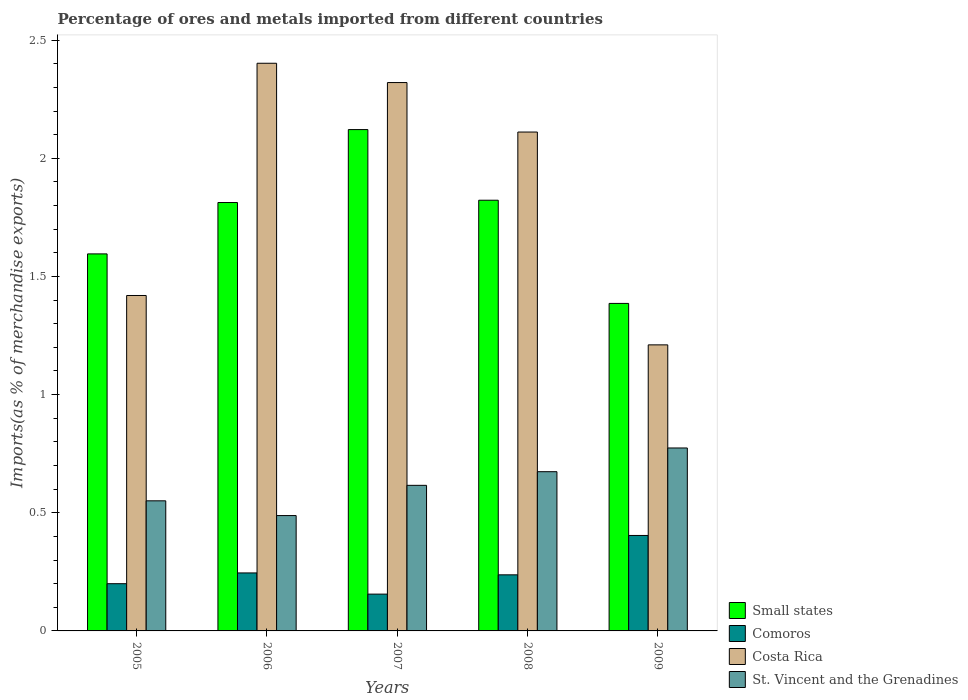How many different coloured bars are there?
Offer a very short reply. 4. How many groups of bars are there?
Ensure brevity in your answer.  5. How many bars are there on the 4th tick from the right?
Provide a short and direct response. 4. What is the label of the 2nd group of bars from the left?
Provide a succinct answer. 2006. In how many cases, is the number of bars for a given year not equal to the number of legend labels?
Your answer should be compact. 0. What is the percentage of imports to different countries in St. Vincent and the Grenadines in 2009?
Provide a succinct answer. 0.77. Across all years, what is the maximum percentage of imports to different countries in Small states?
Keep it short and to the point. 2.12. Across all years, what is the minimum percentage of imports to different countries in Costa Rica?
Your answer should be compact. 1.21. In which year was the percentage of imports to different countries in Small states maximum?
Provide a succinct answer. 2007. What is the total percentage of imports to different countries in Costa Rica in the graph?
Provide a succinct answer. 9.46. What is the difference between the percentage of imports to different countries in St. Vincent and the Grenadines in 2006 and that in 2007?
Your answer should be compact. -0.13. What is the difference between the percentage of imports to different countries in St. Vincent and the Grenadines in 2008 and the percentage of imports to different countries in Small states in 2006?
Make the answer very short. -1.14. What is the average percentage of imports to different countries in Comoros per year?
Provide a short and direct response. 0.25. In the year 2007, what is the difference between the percentage of imports to different countries in Comoros and percentage of imports to different countries in Small states?
Make the answer very short. -1.97. What is the ratio of the percentage of imports to different countries in Comoros in 2007 to that in 2009?
Your answer should be very brief. 0.39. What is the difference between the highest and the second highest percentage of imports to different countries in Comoros?
Your answer should be very brief. 0.16. What is the difference between the highest and the lowest percentage of imports to different countries in Comoros?
Your answer should be very brief. 0.25. Is the sum of the percentage of imports to different countries in St. Vincent and the Grenadines in 2006 and 2009 greater than the maximum percentage of imports to different countries in Comoros across all years?
Keep it short and to the point. Yes. What does the 4th bar from the left in 2005 represents?
Offer a very short reply. St. Vincent and the Grenadines. What does the 1st bar from the right in 2006 represents?
Keep it short and to the point. St. Vincent and the Grenadines. How many bars are there?
Offer a very short reply. 20. What is the difference between two consecutive major ticks on the Y-axis?
Ensure brevity in your answer.  0.5. Are the values on the major ticks of Y-axis written in scientific E-notation?
Provide a succinct answer. No. Does the graph contain any zero values?
Provide a succinct answer. No. Does the graph contain grids?
Provide a succinct answer. No. How are the legend labels stacked?
Ensure brevity in your answer.  Vertical. What is the title of the graph?
Provide a short and direct response. Percentage of ores and metals imported from different countries. Does "Kuwait" appear as one of the legend labels in the graph?
Your answer should be very brief. No. What is the label or title of the X-axis?
Ensure brevity in your answer.  Years. What is the label or title of the Y-axis?
Your answer should be compact. Imports(as % of merchandise exports). What is the Imports(as % of merchandise exports) in Small states in 2005?
Ensure brevity in your answer.  1.6. What is the Imports(as % of merchandise exports) of Comoros in 2005?
Keep it short and to the point. 0.2. What is the Imports(as % of merchandise exports) in Costa Rica in 2005?
Provide a short and direct response. 1.42. What is the Imports(as % of merchandise exports) in St. Vincent and the Grenadines in 2005?
Offer a terse response. 0.55. What is the Imports(as % of merchandise exports) of Small states in 2006?
Provide a short and direct response. 1.81. What is the Imports(as % of merchandise exports) in Comoros in 2006?
Your answer should be compact. 0.25. What is the Imports(as % of merchandise exports) in Costa Rica in 2006?
Provide a short and direct response. 2.4. What is the Imports(as % of merchandise exports) in St. Vincent and the Grenadines in 2006?
Make the answer very short. 0.49. What is the Imports(as % of merchandise exports) of Small states in 2007?
Make the answer very short. 2.12. What is the Imports(as % of merchandise exports) of Comoros in 2007?
Make the answer very short. 0.16. What is the Imports(as % of merchandise exports) in Costa Rica in 2007?
Your answer should be very brief. 2.32. What is the Imports(as % of merchandise exports) of St. Vincent and the Grenadines in 2007?
Give a very brief answer. 0.62. What is the Imports(as % of merchandise exports) of Small states in 2008?
Provide a succinct answer. 1.82. What is the Imports(as % of merchandise exports) of Comoros in 2008?
Keep it short and to the point. 0.24. What is the Imports(as % of merchandise exports) of Costa Rica in 2008?
Offer a terse response. 2.11. What is the Imports(as % of merchandise exports) in St. Vincent and the Grenadines in 2008?
Provide a succinct answer. 0.67. What is the Imports(as % of merchandise exports) in Small states in 2009?
Your answer should be very brief. 1.39. What is the Imports(as % of merchandise exports) of Comoros in 2009?
Keep it short and to the point. 0.4. What is the Imports(as % of merchandise exports) in Costa Rica in 2009?
Your response must be concise. 1.21. What is the Imports(as % of merchandise exports) of St. Vincent and the Grenadines in 2009?
Your answer should be very brief. 0.77. Across all years, what is the maximum Imports(as % of merchandise exports) in Small states?
Provide a short and direct response. 2.12. Across all years, what is the maximum Imports(as % of merchandise exports) in Comoros?
Provide a succinct answer. 0.4. Across all years, what is the maximum Imports(as % of merchandise exports) of Costa Rica?
Your answer should be very brief. 2.4. Across all years, what is the maximum Imports(as % of merchandise exports) of St. Vincent and the Grenadines?
Provide a short and direct response. 0.77. Across all years, what is the minimum Imports(as % of merchandise exports) of Small states?
Offer a terse response. 1.39. Across all years, what is the minimum Imports(as % of merchandise exports) of Comoros?
Keep it short and to the point. 0.16. Across all years, what is the minimum Imports(as % of merchandise exports) in Costa Rica?
Your answer should be compact. 1.21. Across all years, what is the minimum Imports(as % of merchandise exports) of St. Vincent and the Grenadines?
Your response must be concise. 0.49. What is the total Imports(as % of merchandise exports) in Small states in the graph?
Keep it short and to the point. 8.74. What is the total Imports(as % of merchandise exports) of Comoros in the graph?
Give a very brief answer. 1.24. What is the total Imports(as % of merchandise exports) in Costa Rica in the graph?
Make the answer very short. 9.46. What is the total Imports(as % of merchandise exports) of St. Vincent and the Grenadines in the graph?
Keep it short and to the point. 3.1. What is the difference between the Imports(as % of merchandise exports) in Small states in 2005 and that in 2006?
Offer a terse response. -0.22. What is the difference between the Imports(as % of merchandise exports) of Comoros in 2005 and that in 2006?
Provide a succinct answer. -0.05. What is the difference between the Imports(as % of merchandise exports) of Costa Rica in 2005 and that in 2006?
Offer a terse response. -0.98. What is the difference between the Imports(as % of merchandise exports) in St. Vincent and the Grenadines in 2005 and that in 2006?
Give a very brief answer. 0.06. What is the difference between the Imports(as % of merchandise exports) in Small states in 2005 and that in 2007?
Keep it short and to the point. -0.53. What is the difference between the Imports(as % of merchandise exports) of Comoros in 2005 and that in 2007?
Your answer should be very brief. 0.04. What is the difference between the Imports(as % of merchandise exports) in Costa Rica in 2005 and that in 2007?
Your answer should be compact. -0.9. What is the difference between the Imports(as % of merchandise exports) in St. Vincent and the Grenadines in 2005 and that in 2007?
Offer a very short reply. -0.07. What is the difference between the Imports(as % of merchandise exports) of Small states in 2005 and that in 2008?
Ensure brevity in your answer.  -0.23. What is the difference between the Imports(as % of merchandise exports) in Comoros in 2005 and that in 2008?
Offer a terse response. -0.04. What is the difference between the Imports(as % of merchandise exports) in Costa Rica in 2005 and that in 2008?
Keep it short and to the point. -0.69. What is the difference between the Imports(as % of merchandise exports) of St. Vincent and the Grenadines in 2005 and that in 2008?
Your response must be concise. -0.12. What is the difference between the Imports(as % of merchandise exports) in Small states in 2005 and that in 2009?
Provide a succinct answer. 0.21. What is the difference between the Imports(as % of merchandise exports) of Comoros in 2005 and that in 2009?
Your response must be concise. -0.2. What is the difference between the Imports(as % of merchandise exports) in Costa Rica in 2005 and that in 2009?
Your response must be concise. 0.21. What is the difference between the Imports(as % of merchandise exports) of St. Vincent and the Grenadines in 2005 and that in 2009?
Provide a succinct answer. -0.22. What is the difference between the Imports(as % of merchandise exports) in Small states in 2006 and that in 2007?
Your answer should be compact. -0.31. What is the difference between the Imports(as % of merchandise exports) of Comoros in 2006 and that in 2007?
Ensure brevity in your answer.  0.09. What is the difference between the Imports(as % of merchandise exports) of Costa Rica in 2006 and that in 2007?
Provide a succinct answer. 0.08. What is the difference between the Imports(as % of merchandise exports) of St. Vincent and the Grenadines in 2006 and that in 2007?
Provide a short and direct response. -0.13. What is the difference between the Imports(as % of merchandise exports) of Small states in 2006 and that in 2008?
Offer a terse response. -0.01. What is the difference between the Imports(as % of merchandise exports) in Comoros in 2006 and that in 2008?
Your answer should be compact. 0.01. What is the difference between the Imports(as % of merchandise exports) of Costa Rica in 2006 and that in 2008?
Ensure brevity in your answer.  0.29. What is the difference between the Imports(as % of merchandise exports) in St. Vincent and the Grenadines in 2006 and that in 2008?
Provide a succinct answer. -0.19. What is the difference between the Imports(as % of merchandise exports) of Small states in 2006 and that in 2009?
Keep it short and to the point. 0.43. What is the difference between the Imports(as % of merchandise exports) in Comoros in 2006 and that in 2009?
Offer a very short reply. -0.16. What is the difference between the Imports(as % of merchandise exports) of Costa Rica in 2006 and that in 2009?
Offer a terse response. 1.19. What is the difference between the Imports(as % of merchandise exports) in St. Vincent and the Grenadines in 2006 and that in 2009?
Your answer should be very brief. -0.29. What is the difference between the Imports(as % of merchandise exports) of Small states in 2007 and that in 2008?
Your response must be concise. 0.3. What is the difference between the Imports(as % of merchandise exports) in Comoros in 2007 and that in 2008?
Keep it short and to the point. -0.08. What is the difference between the Imports(as % of merchandise exports) of Costa Rica in 2007 and that in 2008?
Ensure brevity in your answer.  0.21. What is the difference between the Imports(as % of merchandise exports) in St. Vincent and the Grenadines in 2007 and that in 2008?
Make the answer very short. -0.06. What is the difference between the Imports(as % of merchandise exports) of Small states in 2007 and that in 2009?
Make the answer very short. 0.74. What is the difference between the Imports(as % of merchandise exports) in Comoros in 2007 and that in 2009?
Provide a succinct answer. -0.25. What is the difference between the Imports(as % of merchandise exports) in Costa Rica in 2007 and that in 2009?
Your response must be concise. 1.11. What is the difference between the Imports(as % of merchandise exports) in St. Vincent and the Grenadines in 2007 and that in 2009?
Provide a succinct answer. -0.16. What is the difference between the Imports(as % of merchandise exports) in Small states in 2008 and that in 2009?
Your answer should be very brief. 0.44. What is the difference between the Imports(as % of merchandise exports) of Comoros in 2008 and that in 2009?
Provide a short and direct response. -0.17. What is the difference between the Imports(as % of merchandise exports) of Costa Rica in 2008 and that in 2009?
Offer a very short reply. 0.9. What is the difference between the Imports(as % of merchandise exports) in St. Vincent and the Grenadines in 2008 and that in 2009?
Your answer should be compact. -0.1. What is the difference between the Imports(as % of merchandise exports) in Small states in 2005 and the Imports(as % of merchandise exports) in Comoros in 2006?
Give a very brief answer. 1.35. What is the difference between the Imports(as % of merchandise exports) in Small states in 2005 and the Imports(as % of merchandise exports) in Costa Rica in 2006?
Keep it short and to the point. -0.81. What is the difference between the Imports(as % of merchandise exports) of Small states in 2005 and the Imports(as % of merchandise exports) of St. Vincent and the Grenadines in 2006?
Your answer should be very brief. 1.11. What is the difference between the Imports(as % of merchandise exports) in Comoros in 2005 and the Imports(as % of merchandise exports) in Costa Rica in 2006?
Provide a short and direct response. -2.2. What is the difference between the Imports(as % of merchandise exports) in Comoros in 2005 and the Imports(as % of merchandise exports) in St. Vincent and the Grenadines in 2006?
Make the answer very short. -0.29. What is the difference between the Imports(as % of merchandise exports) in Costa Rica in 2005 and the Imports(as % of merchandise exports) in St. Vincent and the Grenadines in 2006?
Give a very brief answer. 0.93. What is the difference between the Imports(as % of merchandise exports) of Small states in 2005 and the Imports(as % of merchandise exports) of Comoros in 2007?
Give a very brief answer. 1.44. What is the difference between the Imports(as % of merchandise exports) of Small states in 2005 and the Imports(as % of merchandise exports) of Costa Rica in 2007?
Your response must be concise. -0.73. What is the difference between the Imports(as % of merchandise exports) of Small states in 2005 and the Imports(as % of merchandise exports) of St. Vincent and the Grenadines in 2007?
Your response must be concise. 0.98. What is the difference between the Imports(as % of merchandise exports) of Comoros in 2005 and the Imports(as % of merchandise exports) of Costa Rica in 2007?
Offer a terse response. -2.12. What is the difference between the Imports(as % of merchandise exports) in Comoros in 2005 and the Imports(as % of merchandise exports) in St. Vincent and the Grenadines in 2007?
Offer a very short reply. -0.42. What is the difference between the Imports(as % of merchandise exports) in Costa Rica in 2005 and the Imports(as % of merchandise exports) in St. Vincent and the Grenadines in 2007?
Your answer should be compact. 0.8. What is the difference between the Imports(as % of merchandise exports) in Small states in 2005 and the Imports(as % of merchandise exports) in Comoros in 2008?
Make the answer very short. 1.36. What is the difference between the Imports(as % of merchandise exports) in Small states in 2005 and the Imports(as % of merchandise exports) in Costa Rica in 2008?
Offer a very short reply. -0.52. What is the difference between the Imports(as % of merchandise exports) of Small states in 2005 and the Imports(as % of merchandise exports) of St. Vincent and the Grenadines in 2008?
Offer a terse response. 0.92. What is the difference between the Imports(as % of merchandise exports) of Comoros in 2005 and the Imports(as % of merchandise exports) of Costa Rica in 2008?
Give a very brief answer. -1.91. What is the difference between the Imports(as % of merchandise exports) of Comoros in 2005 and the Imports(as % of merchandise exports) of St. Vincent and the Grenadines in 2008?
Your answer should be very brief. -0.47. What is the difference between the Imports(as % of merchandise exports) of Costa Rica in 2005 and the Imports(as % of merchandise exports) of St. Vincent and the Grenadines in 2008?
Offer a terse response. 0.75. What is the difference between the Imports(as % of merchandise exports) in Small states in 2005 and the Imports(as % of merchandise exports) in Comoros in 2009?
Offer a terse response. 1.19. What is the difference between the Imports(as % of merchandise exports) of Small states in 2005 and the Imports(as % of merchandise exports) of Costa Rica in 2009?
Your answer should be very brief. 0.38. What is the difference between the Imports(as % of merchandise exports) of Small states in 2005 and the Imports(as % of merchandise exports) of St. Vincent and the Grenadines in 2009?
Provide a short and direct response. 0.82. What is the difference between the Imports(as % of merchandise exports) in Comoros in 2005 and the Imports(as % of merchandise exports) in Costa Rica in 2009?
Make the answer very short. -1.01. What is the difference between the Imports(as % of merchandise exports) in Comoros in 2005 and the Imports(as % of merchandise exports) in St. Vincent and the Grenadines in 2009?
Ensure brevity in your answer.  -0.57. What is the difference between the Imports(as % of merchandise exports) in Costa Rica in 2005 and the Imports(as % of merchandise exports) in St. Vincent and the Grenadines in 2009?
Your answer should be compact. 0.65. What is the difference between the Imports(as % of merchandise exports) in Small states in 2006 and the Imports(as % of merchandise exports) in Comoros in 2007?
Provide a short and direct response. 1.66. What is the difference between the Imports(as % of merchandise exports) in Small states in 2006 and the Imports(as % of merchandise exports) in Costa Rica in 2007?
Keep it short and to the point. -0.51. What is the difference between the Imports(as % of merchandise exports) in Small states in 2006 and the Imports(as % of merchandise exports) in St. Vincent and the Grenadines in 2007?
Offer a terse response. 1.2. What is the difference between the Imports(as % of merchandise exports) in Comoros in 2006 and the Imports(as % of merchandise exports) in Costa Rica in 2007?
Ensure brevity in your answer.  -2.08. What is the difference between the Imports(as % of merchandise exports) in Comoros in 2006 and the Imports(as % of merchandise exports) in St. Vincent and the Grenadines in 2007?
Your answer should be compact. -0.37. What is the difference between the Imports(as % of merchandise exports) in Costa Rica in 2006 and the Imports(as % of merchandise exports) in St. Vincent and the Grenadines in 2007?
Make the answer very short. 1.79. What is the difference between the Imports(as % of merchandise exports) in Small states in 2006 and the Imports(as % of merchandise exports) in Comoros in 2008?
Ensure brevity in your answer.  1.58. What is the difference between the Imports(as % of merchandise exports) in Small states in 2006 and the Imports(as % of merchandise exports) in Costa Rica in 2008?
Offer a very short reply. -0.3. What is the difference between the Imports(as % of merchandise exports) of Small states in 2006 and the Imports(as % of merchandise exports) of St. Vincent and the Grenadines in 2008?
Your response must be concise. 1.14. What is the difference between the Imports(as % of merchandise exports) of Comoros in 2006 and the Imports(as % of merchandise exports) of Costa Rica in 2008?
Your answer should be compact. -1.87. What is the difference between the Imports(as % of merchandise exports) of Comoros in 2006 and the Imports(as % of merchandise exports) of St. Vincent and the Grenadines in 2008?
Your answer should be very brief. -0.43. What is the difference between the Imports(as % of merchandise exports) in Costa Rica in 2006 and the Imports(as % of merchandise exports) in St. Vincent and the Grenadines in 2008?
Offer a terse response. 1.73. What is the difference between the Imports(as % of merchandise exports) in Small states in 2006 and the Imports(as % of merchandise exports) in Comoros in 2009?
Keep it short and to the point. 1.41. What is the difference between the Imports(as % of merchandise exports) of Small states in 2006 and the Imports(as % of merchandise exports) of Costa Rica in 2009?
Offer a very short reply. 0.6. What is the difference between the Imports(as % of merchandise exports) of Small states in 2006 and the Imports(as % of merchandise exports) of St. Vincent and the Grenadines in 2009?
Offer a very short reply. 1.04. What is the difference between the Imports(as % of merchandise exports) in Comoros in 2006 and the Imports(as % of merchandise exports) in Costa Rica in 2009?
Offer a terse response. -0.97. What is the difference between the Imports(as % of merchandise exports) in Comoros in 2006 and the Imports(as % of merchandise exports) in St. Vincent and the Grenadines in 2009?
Provide a short and direct response. -0.53. What is the difference between the Imports(as % of merchandise exports) of Costa Rica in 2006 and the Imports(as % of merchandise exports) of St. Vincent and the Grenadines in 2009?
Ensure brevity in your answer.  1.63. What is the difference between the Imports(as % of merchandise exports) in Small states in 2007 and the Imports(as % of merchandise exports) in Comoros in 2008?
Provide a short and direct response. 1.88. What is the difference between the Imports(as % of merchandise exports) of Small states in 2007 and the Imports(as % of merchandise exports) of Costa Rica in 2008?
Ensure brevity in your answer.  0.01. What is the difference between the Imports(as % of merchandise exports) in Small states in 2007 and the Imports(as % of merchandise exports) in St. Vincent and the Grenadines in 2008?
Offer a terse response. 1.45. What is the difference between the Imports(as % of merchandise exports) in Comoros in 2007 and the Imports(as % of merchandise exports) in Costa Rica in 2008?
Keep it short and to the point. -1.96. What is the difference between the Imports(as % of merchandise exports) in Comoros in 2007 and the Imports(as % of merchandise exports) in St. Vincent and the Grenadines in 2008?
Give a very brief answer. -0.52. What is the difference between the Imports(as % of merchandise exports) in Costa Rica in 2007 and the Imports(as % of merchandise exports) in St. Vincent and the Grenadines in 2008?
Provide a succinct answer. 1.65. What is the difference between the Imports(as % of merchandise exports) of Small states in 2007 and the Imports(as % of merchandise exports) of Comoros in 2009?
Your answer should be very brief. 1.72. What is the difference between the Imports(as % of merchandise exports) in Small states in 2007 and the Imports(as % of merchandise exports) in Costa Rica in 2009?
Ensure brevity in your answer.  0.91. What is the difference between the Imports(as % of merchandise exports) of Small states in 2007 and the Imports(as % of merchandise exports) of St. Vincent and the Grenadines in 2009?
Ensure brevity in your answer.  1.35. What is the difference between the Imports(as % of merchandise exports) of Comoros in 2007 and the Imports(as % of merchandise exports) of Costa Rica in 2009?
Your answer should be very brief. -1.05. What is the difference between the Imports(as % of merchandise exports) in Comoros in 2007 and the Imports(as % of merchandise exports) in St. Vincent and the Grenadines in 2009?
Provide a succinct answer. -0.62. What is the difference between the Imports(as % of merchandise exports) of Costa Rica in 2007 and the Imports(as % of merchandise exports) of St. Vincent and the Grenadines in 2009?
Give a very brief answer. 1.55. What is the difference between the Imports(as % of merchandise exports) in Small states in 2008 and the Imports(as % of merchandise exports) in Comoros in 2009?
Provide a short and direct response. 1.42. What is the difference between the Imports(as % of merchandise exports) in Small states in 2008 and the Imports(as % of merchandise exports) in Costa Rica in 2009?
Your answer should be compact. 0.61. What is the difference between the Imports(as % of merchandise exports) in Small states in 2008 and the Imports(as % of merchandise exports) in St. Vincent and the Grenadines in 2009?
Make the answer very short. 1.05. What is the difference between the Imports(as % of merchandise exports) in Comoros in 2008 and the Imports(as % of merchandise exports) in Costa Rica in 2009?
Make the answer very short. -0.97. What is the difference between the Imports(as % of merchandise exports) of Comoros in 2008 and the Imports(as % of merchandise exports) of St. Vincent and the Grenadines in 2009?
Give a very brief answer. -0.54. What is the difference between the Imports(as % of merchandise exports) in Costa Rica in 2008 and the Imports(as % of merchandise exports) in St. Vincent and the Grenadines in 2009?
Offer a terse response. 1.34. What is the average Imports(as % of merchandise exports) of Small states per year?
Provide a succinct answer. 1.75. What is the average Imports(as % of merchandise exports) in Comoros per year?
Your response must be concise. 0.25. What is the average Imports(as % of merchandise exports) in Costa Rica per year?
Keep it short and to the point. 1.89. What is the average Imports(as % of merchandise exports) of St. Vincent and the Grenadines per year?
Provide a succinct answer. 0.62. In the year 2005, what is the difference between the Imports(as % of merchandise exports) of Small states and Imports(as % of merchandise exports) of Comoros?
Make the answer very short. 1.4. In the year 2005, what is the difference between the Imports(as % of merchandise exports) of Small states and Imports(as % of merchandise exports) of Costa Rica?
Your response must be concise. 0.18. In the year 2005, what is the difference between the Imports(as % of merchandise exports) in Small states and Imports(as % of merchandise exports) in St. Vincent and the Grenadines?
Your response must be concise. 1.04. In the year 2005, what is the difference between the Imports(as % of merchandise exports) of Comoros and Imports(as % of merchandise exports) of Costa Rica?
Your answer should be compact. -1.22. In the year 2005, what is the difference between the Imports(as % of merchandise exports) in Comoros and Imports(as % of merchandise exports) in St. Vincent and the Grenadines?
Ensure brevity in your answer.  -0.35. In the year 2005, what is the difference between the Imports(as % of merchandise exports) in Costa Rica and Imports(as % of merchandise exports) in St. Vincent and the Grenadines?
Offer a terse response. 0.87. In the year 2006, what is the difference between the Imports(as % of merchandise exports) of Small states and Imports(as % of merchandise exports) of Comoros?
Your response must be concise. 1.57. In the year 2006, what is the difference between the Imports(as % of merchandise exports) of Small states and Imports(as % of merchandise exports) of Costa Rica?
Offer a terse response. -0.59. In the year 2006, what is the difference between the Imports(as % of merchandise exports) in Small states and Imports(as % of merchandise exports) in St. Vincent and the Grenadines?
Your answer should be compact. 1.32. In the year 2006, what is the difference between the Imports(as % of merchandise exports) of Comoros and Imports(as % of merchandise exports) of Costa Rica?
Keep it short and to the point. -2.16. In the year 2006, what is the difference between the Imports(as % of merchandise exports) of Comoros and Imports(as % of merchandise exports) of St. Vincent and the Grenadines?
Your answer should be very brief. -0.24. In the year 2006, what is the difference between the Imports(as % of merchandise exports) of Costa Rica and Imports(as % of merchandise exports) of St. Vincent and the Grenadines?
Give a very brief answer. 1.91. In the year 2007, what is the difference between the Imports(as % of merchandise exports) in Small states and Imports(as % of merchandise exports) in Comoros?
Keep it short and to the point. 1.97. In the year 2007, what is the difference between the Imports(as % of merchandise exports) of Small states and Imports(as % of merchandise exports) of Costa Rica?
Your response must be concise. -0.2. In the year 2007, what is the difference between the Imports(as % of merchandise exports) of Small states and Imports(as % of merchandise exports) of St. Vincent and the Grenadines?
Ensure brevity in your answer.  1.51. In the year 2007, what is the difference between the Imports(as % of merchandise exports) of Comoros and Imports(as % of merchandise exports) of Costa Rica?
Offer a very short reply. -2.16. In the year 2007, what is the difference between the Imports(as % of merchandise exports) of Comoros and Imports(as % of merchandise exports) of St. Vincent and the Grenadines?
Offer a terse response. -0.46. In the year 2007, what is the difference between the Imports(as % of merchandise exports) in Costa Rica and Imports(as % of merchandise exports) in St. Vincent and the Grenadines?
Offer a terse response. 1.7. In the year 2008, what is the difference between the Imports(as % of merchandise exports) in Small states and Imports(as % of merchandise exports) in Comoros?
Keep it short and to the point. 1.59. In the year 2008, what is the difference between the Imports(as % of merchandise exports) in Small states and Imports(as % of merchandise exports) in Costa Rica?
Provide a short and direct response. -0.29. In the year 2008, what is the difference between the Imports(as % of merchandise exports) in Small states and Imports(as % of merchandise exports) in St. Vincent and the Grenadines?
Your response must be concise. 1.15. In the year 2008, what is the difference between the Imports(as % of merchandise exports) in Comoros and Imports(as % of merchandise exports) in Costa Rica?
Your response must be concise. -1.87. In the year 2008, what is the difference between the Imports(as % of merchandise exports) in Comoros and Imports(as % of merchandise exports) in St. Vincent and the Grenadines?
Make the answer very short. -0.44. In the year 2008, what is the difference between the Imports(as % of merchandise exports) in Costa Rica and Imports(as % of merchandise exports) in St. Vincent and the Grenadines?
Make the answer very short. 1.44. In the year 2009, what is the difference between the Imports(as % of merchandise exports) of Small states and Imports(as % of merchandise exports) of Costa Rica?
Ensure brevity in your answer.  0.18. In the year 2009, what is the difference between the Imports(as % of merchandise exports) in Small states and Imports(as % of merchandise exports) in St. Vincent and the Grenadines?
Make the answer very short. 0.61. In the year 2009, what is the difference between the Imports(as % of merchandise exports) in Comoros and Imports(as % of merchandise exports) in Costa Rica?
Keep it short and to the point. -0.81. In the year 2009, what is the difference between the Imports(as % of merchandise exports) of Comoros and Imports(as % of merchandise exports) of St. Vincent and the Grenadines?
Provide a succinct answer. -0.37. In the year 2009, what is the difference between the Imports(as % of merchandise exports) of Costa Rica and Imports(as % of merchandise exports) of St. Vincent and the Grenadines?
Give a very brief answer. 0.44. What is the ratio of the Imports(as % of merchandise exports) in Small states in 2005 to that in 2006?
Ensure brevity in your answer.  0.88. What is the ratio of the Imports(as % of merchandise exports) in Comoros in 2005 to that in 2006?
Ensure brevity in your answer.  0.81. What is the ratio of the Imports(as % of merchandise exports) of Costa Rica in 2005 to that in 2006?
Keep it short and to the point. 0.59. What is the ratio of the Imports(as % of merchandise exports) in St. Vincent and the Grenadines in 2005 to that in 2006?
Your response must be concise. 1.13. What is the ratio of the Imports(as % of merchandise exports) in Small states in 2005 to that in 2007?
Offer a terse response. 0.75. What is the ratio of the Imports(as % of merchandise exports) of Comoros in 2005 to that in 2007?
Your answer should be compact. 1.28. What is the ratio of the Imports(as % of merchandise exports) of Costa Rica in 2005 to that in 2007?
Your response must be concise. 0.61. What is the ratio of the Imports(as % of merchandise exports) of St. Vincent and the Grenadines in 2005 to that in 2007?
Keep it short and to the point. 0.89. What is the ratio of the Imports(as % of merchandise exports) in Small states in 2005 to that in 2008?
Your answer should be very brief. 0.88. What is the ratio of the Imports(as % of merchandise exports) in Comoros in 2005 to that in 2008?
Provide a succinct answer. 0.84. What is the ratio of the Imports(as % of merchandise exports) in Costa Rica in 2005 to that in 2008?
Keep it short and to the point. 0.67. What is the ratio of the Imports(as % of merchandise exports) in St. Vincent and the Grenadines in 2005 to that in 2008?
Offer a terse response. 0.82. What is the ratio of the Imports(as % of merchandise exports) in Small states in 2005 to that in 2009?
Your answer should be compact. 1.15. What is the ratio of the Imports(as % of merchandise exports) of Comoros in 2005 to that in 2009?
Make the answer very short. 0.49. What is the ratio of the Imports(as % of merchandise exports) of Costa Rica in 2005 to that in 2009?
Keep it short and to the point. 1.17. What is the ratio of the Imports(as % of merchandise exports) of St. Vincent and the Grenadines in 2005 to that in 2009?
Give a very brief answer. 0.71. What is the ratio of the Imports(as % of merchandise exports) in Small states in 2006 to that in 2007?
Keep it short and to the point. 0.85. What is the ratio of the Imports(as % of merchandise exports) in Comoros in 2006 to that in 2007?
Your answer should be very brief. 1.58. What is the ratio of the Imports(as % of merchandise exports) of Costa Rica in 2006 to that in 2007?
Offer a terse response. 1.04. What is the ratio of the Imports(as % of merchandise exports) in St. Vincent and the Grenadines in 2006 to that in 2007?
Your answer should be very brief. 0.79. What is the ratio of the Imports(as % of merchandise exports) in Small states in 2006 to that in 2008?
Offer a very short reply. 0.99. What is the ratio of the Imports(as % of merchandise exports) in Comoros in 2006 to that in 2008?
Offer a terse response. 1.03. What is the ratio of the Imports(as % of merchandise exports) in Costa Rica in 2006 to that in 2008?
Provide a short and direct response. 1.14. What is the ratio of the Imports(as % of merchandise exports) of St. Vincent and the Grenadines in 2006 to that in 2008?
Offer a very short reply. 0.72. What is the ratio of the Imports(as % of merchandise exports) in Small states in 2006 to that in 2009?
Keep it short and to the point. 1.31. What is the ratio of the Imports(as % of merchandise exports) in Comoros in 2006 to that in 2009?
Your answer should be very brief. 0.61. What is the ratio of the Imports(as % of merchandise exports) of Costa Rica in 2006 to that in 2009?
Give a very brief answer. 1.98. What is the ratio of the Imports(as % of merchandise exports) of St. Vincent and the Grenadines in 2006 to that in 2009?
Provide a short and direct response. 0.63. What is the ratio of the Imports(as % of merchandise exports) in Small states in 2007 to that in 2008?
Give a very brief answer. 1.16. What is the ratio of the Imports(as % of merchandise exports) of Comoros in 2007 to that in 2008?
Make the answer very short. 0.66. What is the ratio of the Imports(as % of merchandise exports) in Costa Rica in 2007 to that in 2008?
Your response must be concise. 1.1. What is the ratio of the Imports(as % of merchandise exports) in St. Vincent and the Grenadines in 2007 to that in 2008?
Keep it short and to the point. 0.91. What is the ratio of the Imports(as % of merchandise exports) of Small states in 2007 to that in 2009?
Offer a very short reply. 1.53. What is the ratio of the Imports(as % of merchandise exports) in Comoros in 2007 to that in 2009?
Provide a succinct answer. 0.39. What is the ratio of the Imports(as % of merchandise exports) in Costa Rica in 2007 to that in 2009?
Make the answer very short. 1.92. What is the ratio of the Imports(as % of merchandise exports) of St. Vincent and the Grenadines in 2007 to that in 2009?
Your response must be concise. 0.8. What is the ratio of the Imports(as % of merchandise exports) of Small states in 2008 to that in 2009?
Keep it short and to the point. 1.31. What is the ratio of the Imports(as % of merchandise exports) in Comoros in 2008 to that in 2009?
Provide a short and direct response. 0.59. What is the ratio of the Imports(as % of merchandise exports) in Costa Rica in 2008 to that in 2009?
Offer a terse response. 1.74. What is the ratio of the Imports(as % of merchandise exports) of St. Vincent and the Grenadines in 2008 to that in 2009?
Your response must be concise. 0.87. What is the difference between the highest and the second highest Imports(as % of merchandise exports) of Small states?
Your response must be concise. 0.3. What is the difference between the highest and the second highest Imports(as % of merchandise exports) in Comoros?
Make the answer very short. 0.16. What is the difference between the highest and the second highest Imports(as % of merchandise exports) in Costa Rica?
Make the answer very short. 0.08. What is the difference between the highest and the second highest Imports(as % of merchandise exports) of St. Vincent and the Grenadines?
Give a very brief answer. 0.1. What is the difference between the highest and the lowest Imports(as % of merchandise exports) of Small states?
Give a very brief answer. 0.74. What is the difference between the highest and the lowest Imports(as % of merchandise exports) of Comoros?
Provide a succinct answer. 0.25. What is the difference between the highest and the lowest Imports(as % of merchandise exports) in Costa Rica?
Give a very brief answer. 1.19. What is the difference between the highest and the lowest Imports(as % of merchandise exports) in St. Vincent and the Grenadines?
Offer a terse response. 0.29. 